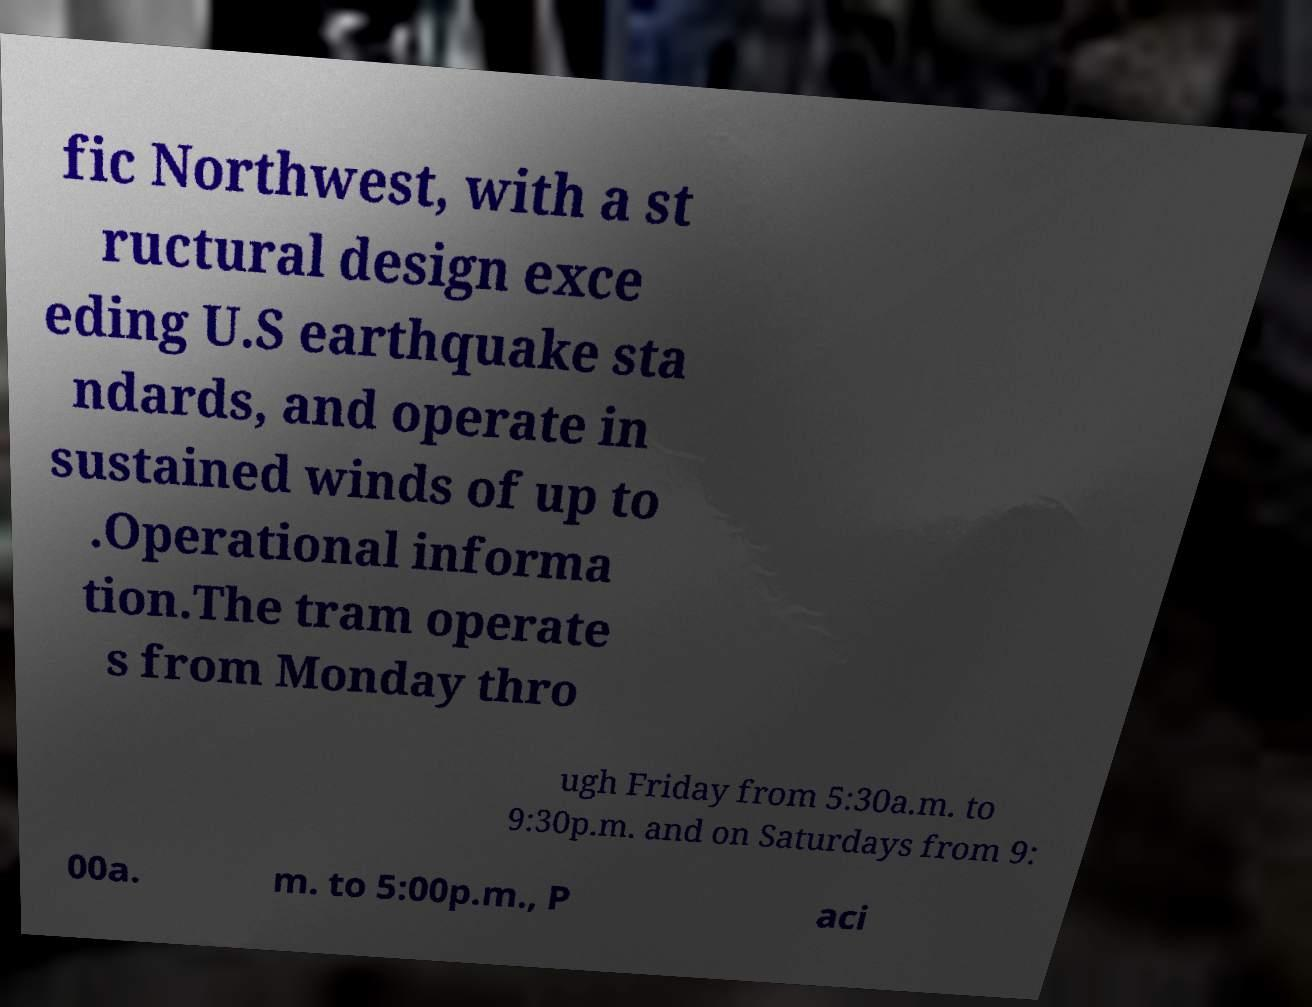Can you read and provide the text displayed in the image?This photo seems to have some interesting text. Can you extract and type it out for me? fic Northwest, with a st ructural design exce eding U.S earthquake sta ndards, and operate in sustained winds of up to .Operational informa tion.The tram operate s from Monday thro ugh Friday from 5:30a.m. to 9:30p.m. and on Saturdays from 9: 00a. m. to 5:00p.m., P aci 